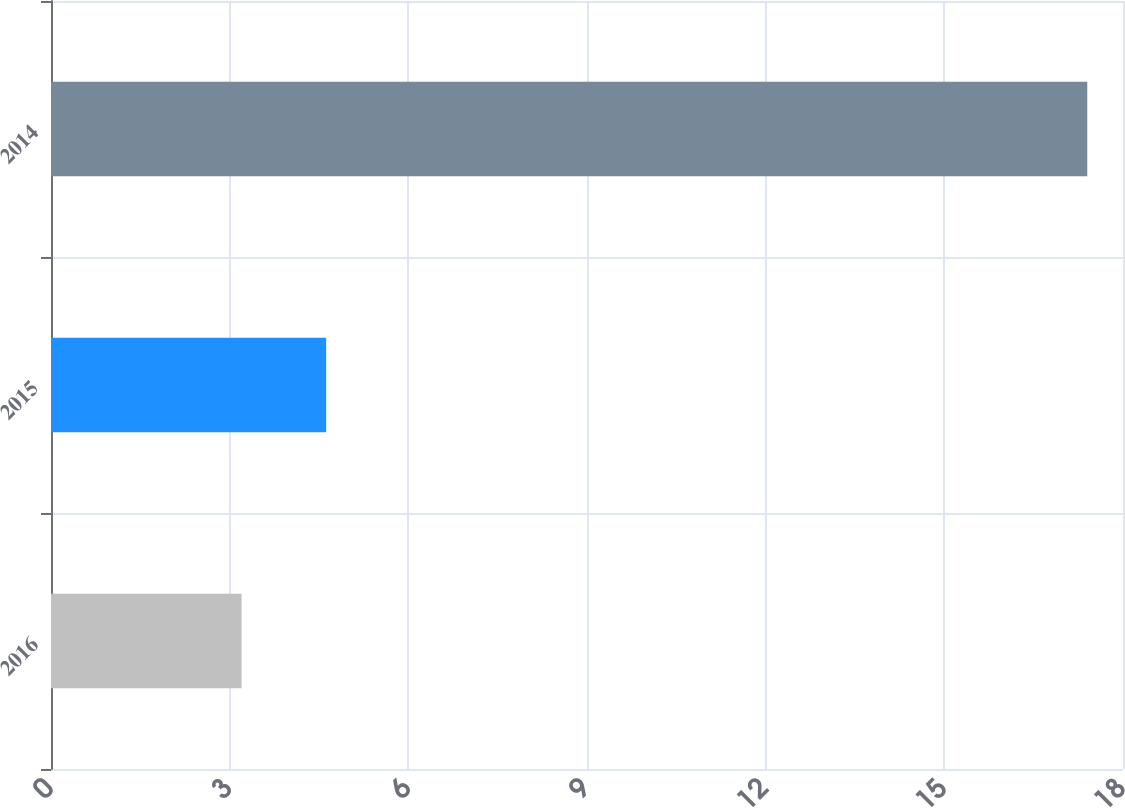Convert chart to OTSL. <chart><loc_0><loc_0><loc_500><loc_500><bar_chart><fcel>2016<fcel>2015<fcel>2014<nl><fcel>3.2<fcel>4.62<fcel>17.4<nl></chart> 